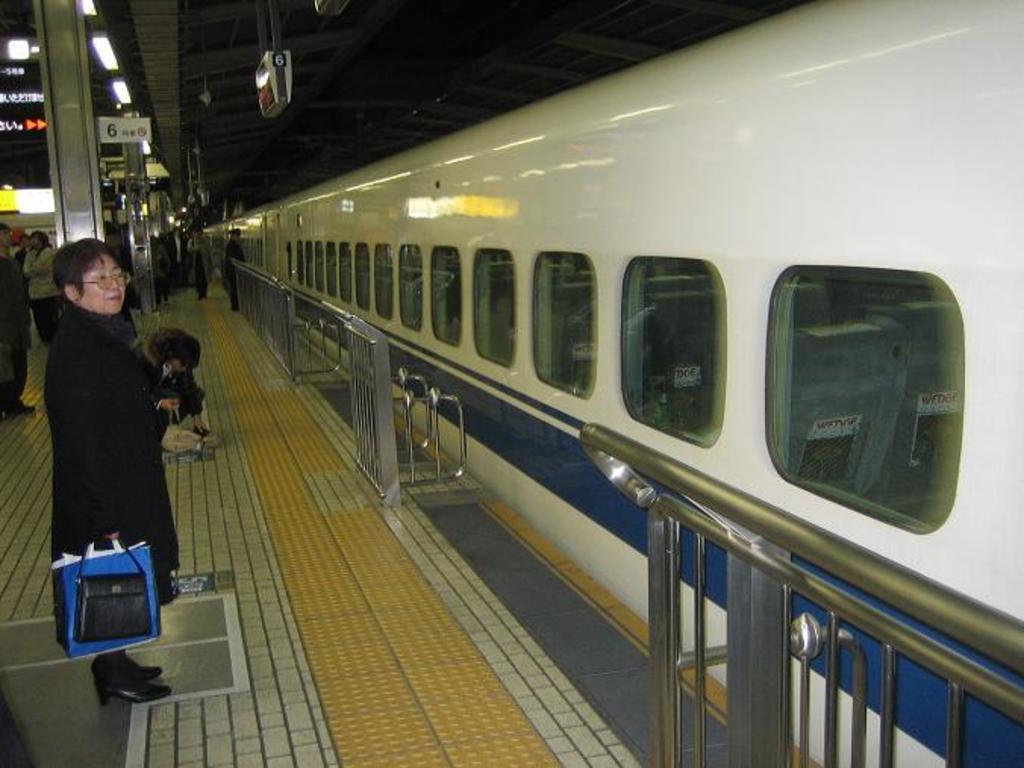In one or two sentences, can you explain what this image depicts? In this picture I can observe a railway station. There are some people standing on the platform. I can observe a railing. On the right side I can observe a train which is in white and blue color. I can observe some lights on the left side. 